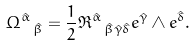<formula> <loc_0><loc_0><loc_500><loc_500>\Omega ^ { \hat { \alpha } } \, _ { \hat { \beta } } = \frac { 1 } { 2 } \Re ^ { \hat { \alpha } } \, _ { \hat { \beta } \hat { \gamma } \hat { \delta } } e ^ { \hat { \gamma } } \wedge e ^ { \hat { \delta } } .</formula> 